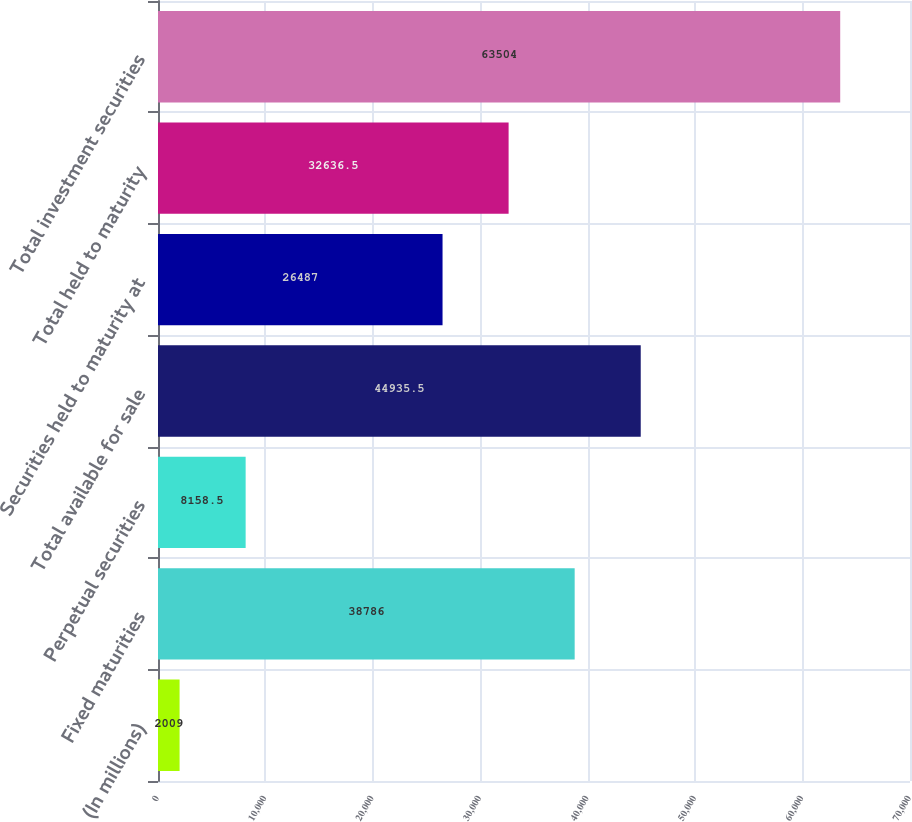<chart> <loc_0><loc_0><loc_500><loc_500><bar_chart><fcel>(In millions)<fcel>Fixed maturities<fcel>Perpetual securities<fcel>Total available for sale<fcel>Securities held to maturity at<fcel>Total held to maturity<fcel>Total investment securities<nl><fcel>2009<fcel>38786<fcel>8158.5<fcel>44935.5<fcel>26487<fcel>32636.5<fcel>63504<nl></chart> 